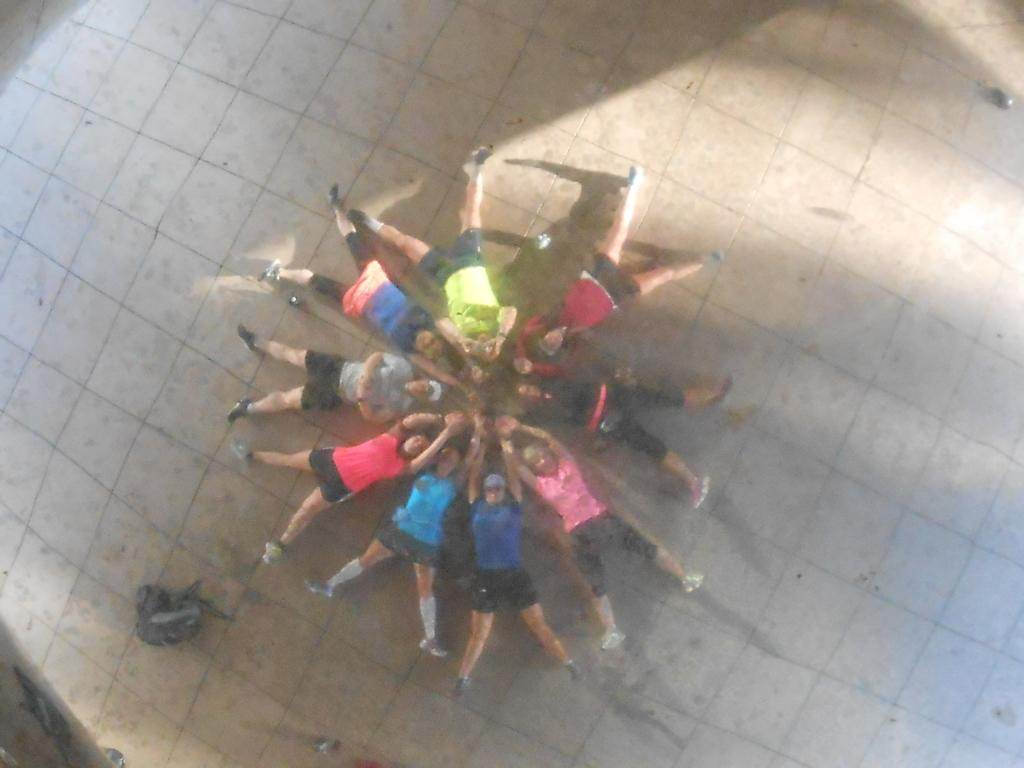How many people are in the image? There is a group of persons in the image. What are the persons in the image doing? The persons are lying on the ground. What type of drain is visible in the image? There is no drain present in the image. What theory can be observed being tested in the image? There is no theory being tested in the image; it simply shows a group of persons lying on the ground. 